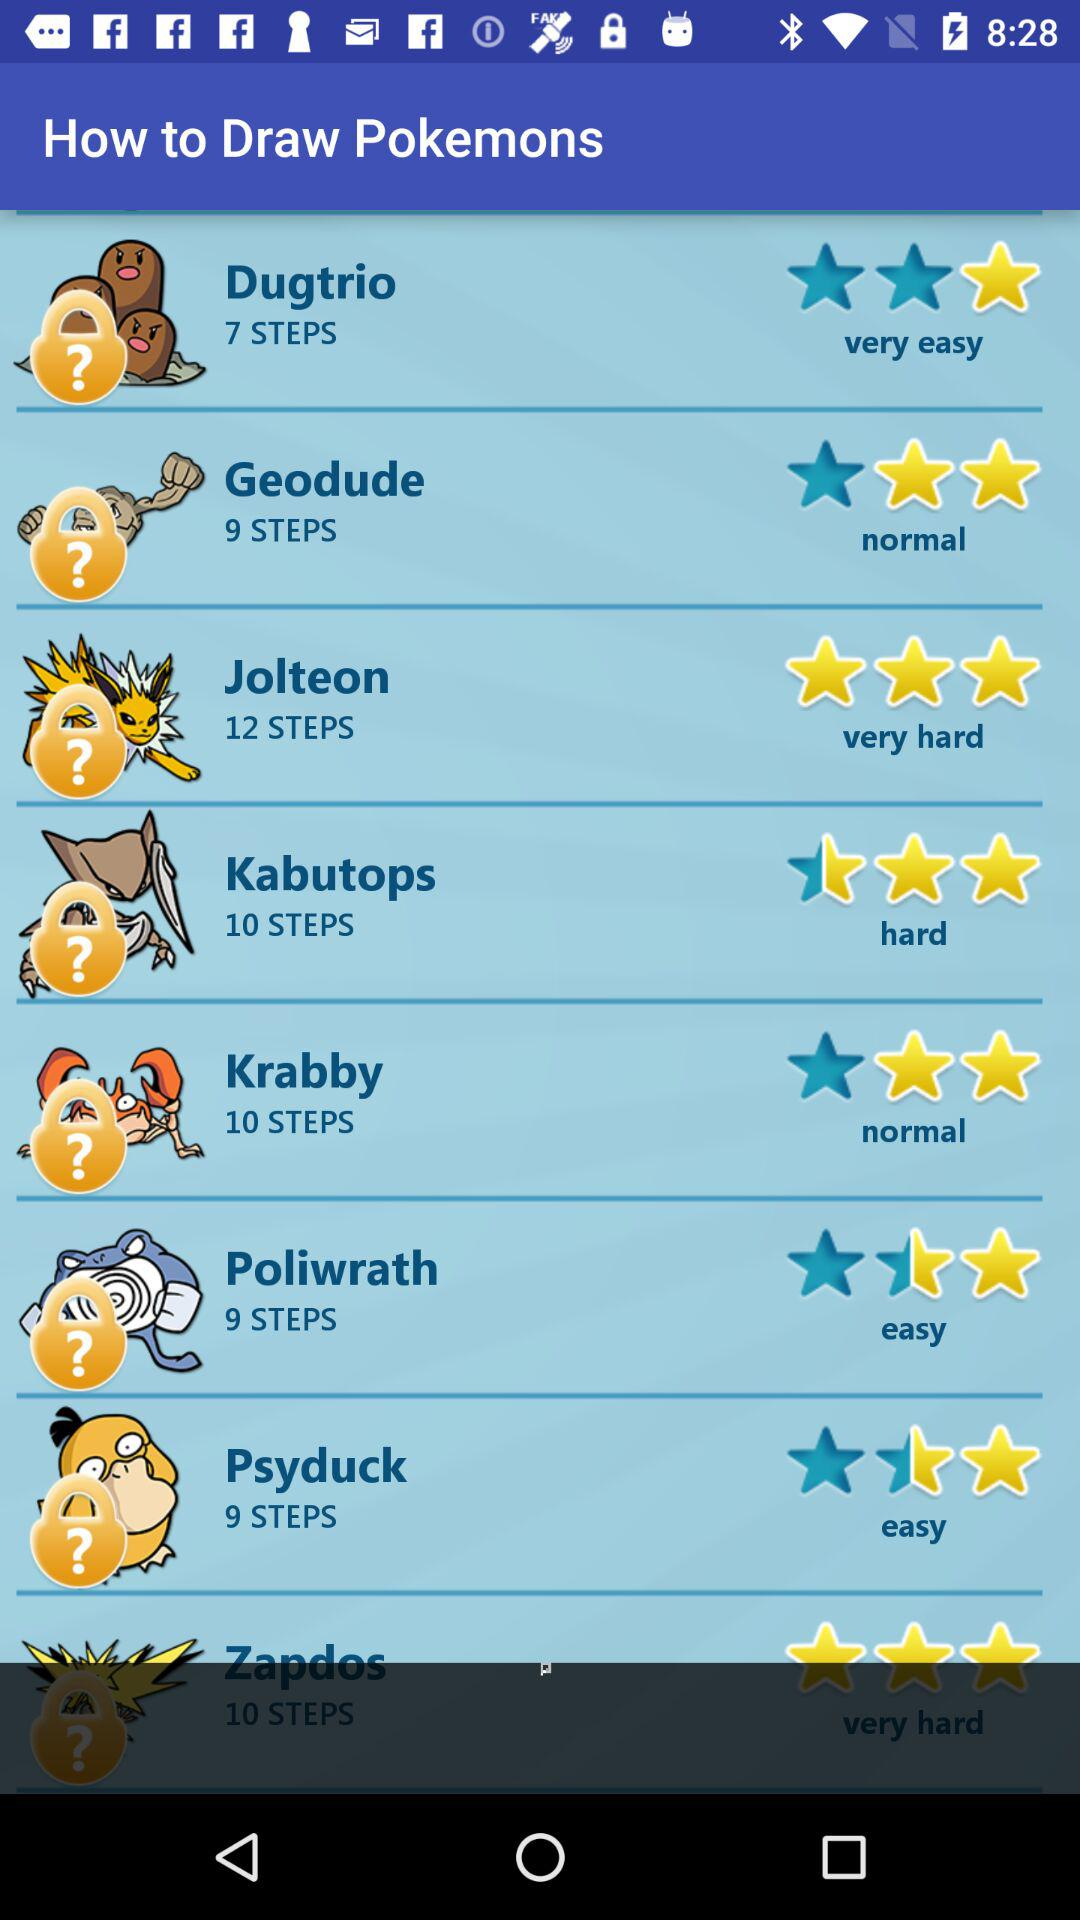How many steps does "Poliwrath" have? "Poliwrath" has 9 steps. 